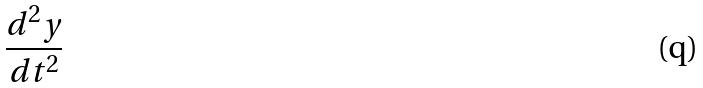<formula> <loc_0><loc_0><loc_500><loc_500>\frac { d ^ { 2 } y } { d t ^ { 2 } }</formula> 